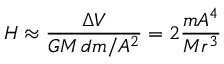<formula> <loc_0><loc_0><loc_500><loc_500>H \approx { \frac { \Delta V } { G M \, d m / A ^ { 2 } } } = 2 { \frac { m A ^ { 4 } } { M r ^ { 3 } } }</formula> 